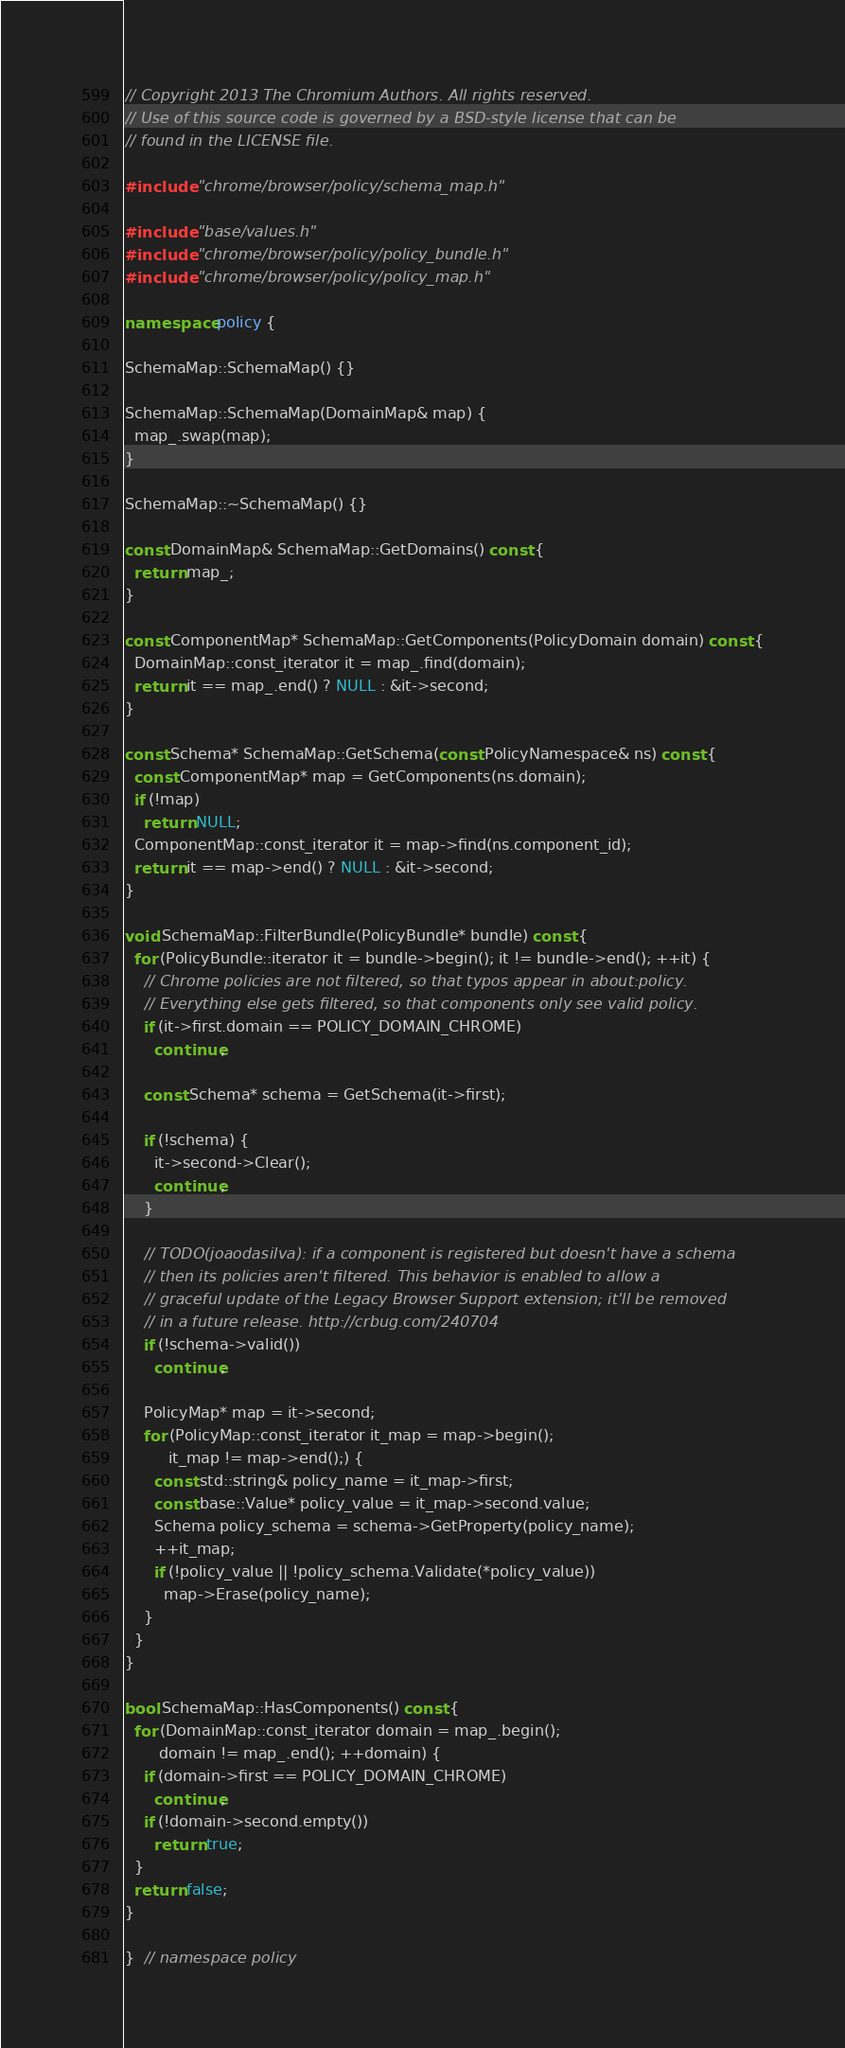Convert code to text. <code><loc_0><loc_0><loc_500><loc_500><_C++_>// Copyright 2013 The Chromium Authors. All rights reserved.
// Use of this source code is governed by a BSD-style license that can be
// found in the LICENSE file.

#include "chrome/browser/policy/schema_map.h"

#include "base/values.h"
#include "chrome/browser/policy/policy_bundle.h"
#include "chrome/browser/policy/policy_map.h"

namespace policy {

SchemaMap::SchemaMap() {}

SchemaMap::SchemaMap(DomainMap& map) {
  map_.swap(map);
}

SchemaMap::~SchemaMap() {}

const DomainMap& SchemaMap::GetDomains() const {
  return map_;
}

const ComponentMap* SchemaMap::GetComponents(PolicyDomain domain) const {
  DomainMap::const_iterator it = map_.find(domain);
  return it == map_.end() ? NULL : &it->second;
}

const Schema* SchemaMap::GetSchema(const PolicyNamespace& ns) const {
  const ComponentMap* map = GetComponents(ns.domain);
  if (!map)
    return NULL;
  ComponentMap::const_iterator it = map->find(ns.component_id);
  return it == map->end() ? NULL : &it->second;
}

void SchemaMap::FilterBundle(PolicyBundle* bundle) const {
  for (PolicyBundle::iterator it = bundle->begin(); it != bundle->end(); ++it) {
    // Chrome policies are not filtered, so that typos appear in about:policy.
    // Everything else gets filtered, so that components only see valid policy.
    if (it->first.domain == POLICY_DOMAIN_CHROME)
      continue;

    const Schema* schema = GetSchema(it->first);

    if (!schema) {
      it->second->Clear();
      continue;
    }

    // TODO(joaodasilva): if a component is registered but doesn't have a schema
    // then its policies aren't filtered. This behavior is enabled to allow a
    // graceful update of the Legacy Browser Support extension; it'll be removed
    // in a future release. http://crbug.com/240704
    if (!schema->valid())
      continue;

    PolicyMap* map = it->second;
    for (PolicyMap::const_iterator it_map = map->begin();
         it_map != map->end();) {
      const std::string& policy_name = it_map->first;
      const base::Value* policy_value = it_map->second.value;
      Schema policy_schema = schema->GetProperty(policy_name);
      ++it_map;
      if (!policy_value || !policy_schema.Validate(*policy_value))
        map->Erase(policy_name);
    }
  }
}

bool SchemaMap::HasComponents() const {
  for (DomainMap::const_iterator domain = map_.begin();
       domain != map_.end(); ++domain) {
    if (domain->first == POLICY_DOMAIN_CHROME)
      continue;
    if (!domain->second.empty())
      return true;
  }
  return false;
}

}  // namespace policy
</code> 